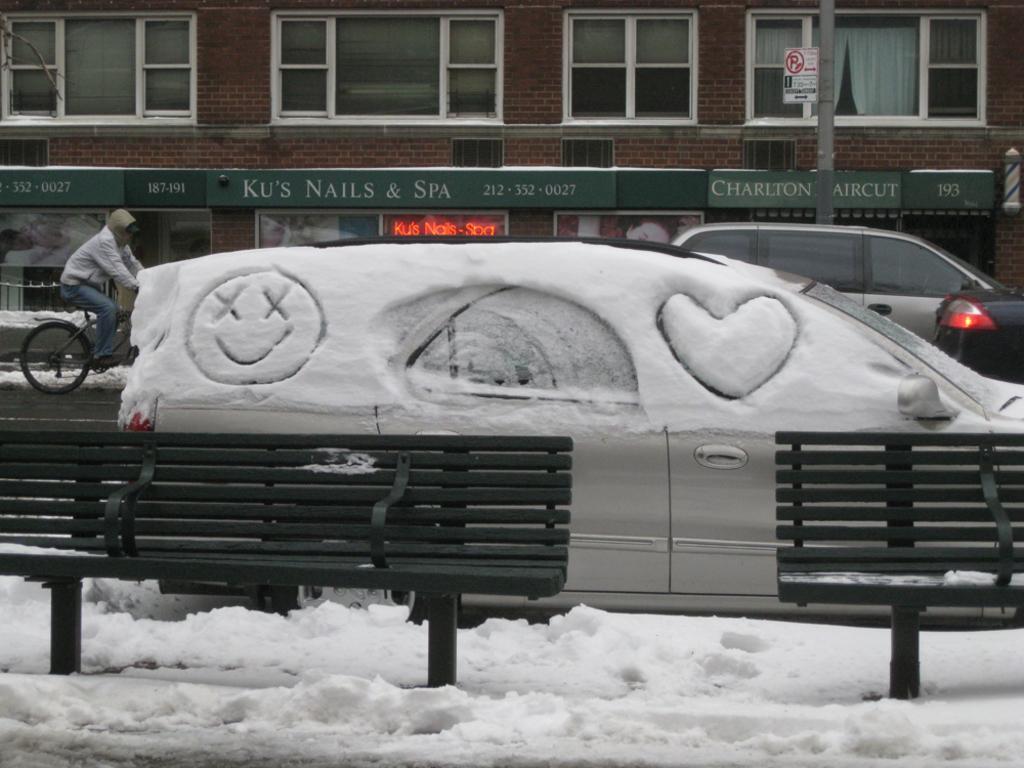Could you give a brief overview of what you see in this image? In the image we can see there is a ground covered with snow and there are benches kept on the ground. Behind there are cars parked on the road and there is a person sitting on the bicycle. There is a building at the back and there is an iron pole on the ground. 